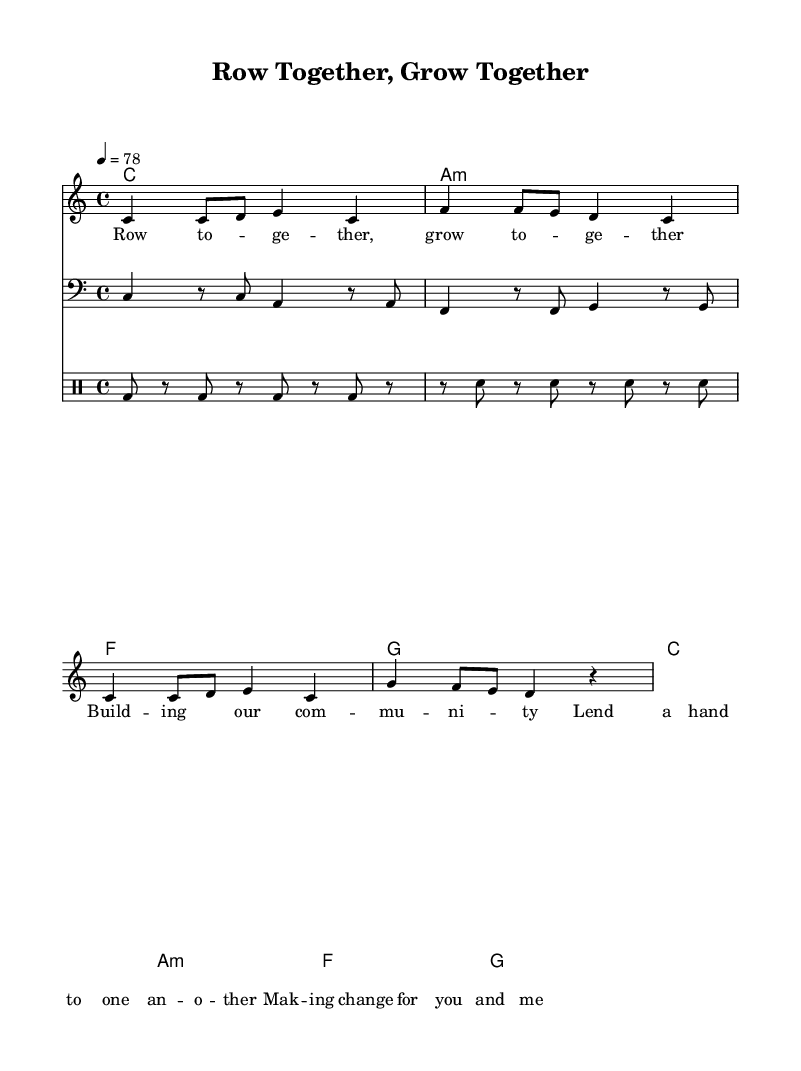What is the key signature of this music? The key signature is C major, which has no sharps or flats.
Answer: C major What is the time signature of the piece? The time signature is indicated at the beginning of the score as 4/4, meaning there are four beats in every measure.
Answer: 4/4 What is the tempo marking for this piece? The tempo marking is given as quarter note equals seventy-eight beats per minute, indicating the speed of the music.
Answer: 78 How many measures are there in the melody? Counting the individual measures in the melody section shows a total of four measures.
Answer: 4 What is the first chord in the progression? The first chord in the chord progression is specified in the score as C major, which is indicated in the chord names section.
Answer: C What type of song is represented by the title "Row Together, Grow Together"? The title suggests a reggae anthem that emphasizes community living and social development, aligning with the themes often present in reggae music.
Answer: Reggae anthem How does the drum pattern reflect reggae music style? The drum pattern incorporates a typical reggae rhythm, emphasizing the backbeat with bass drum and snare interplay, which is characteristic of the genre.
Answer: Reggae rhythm 